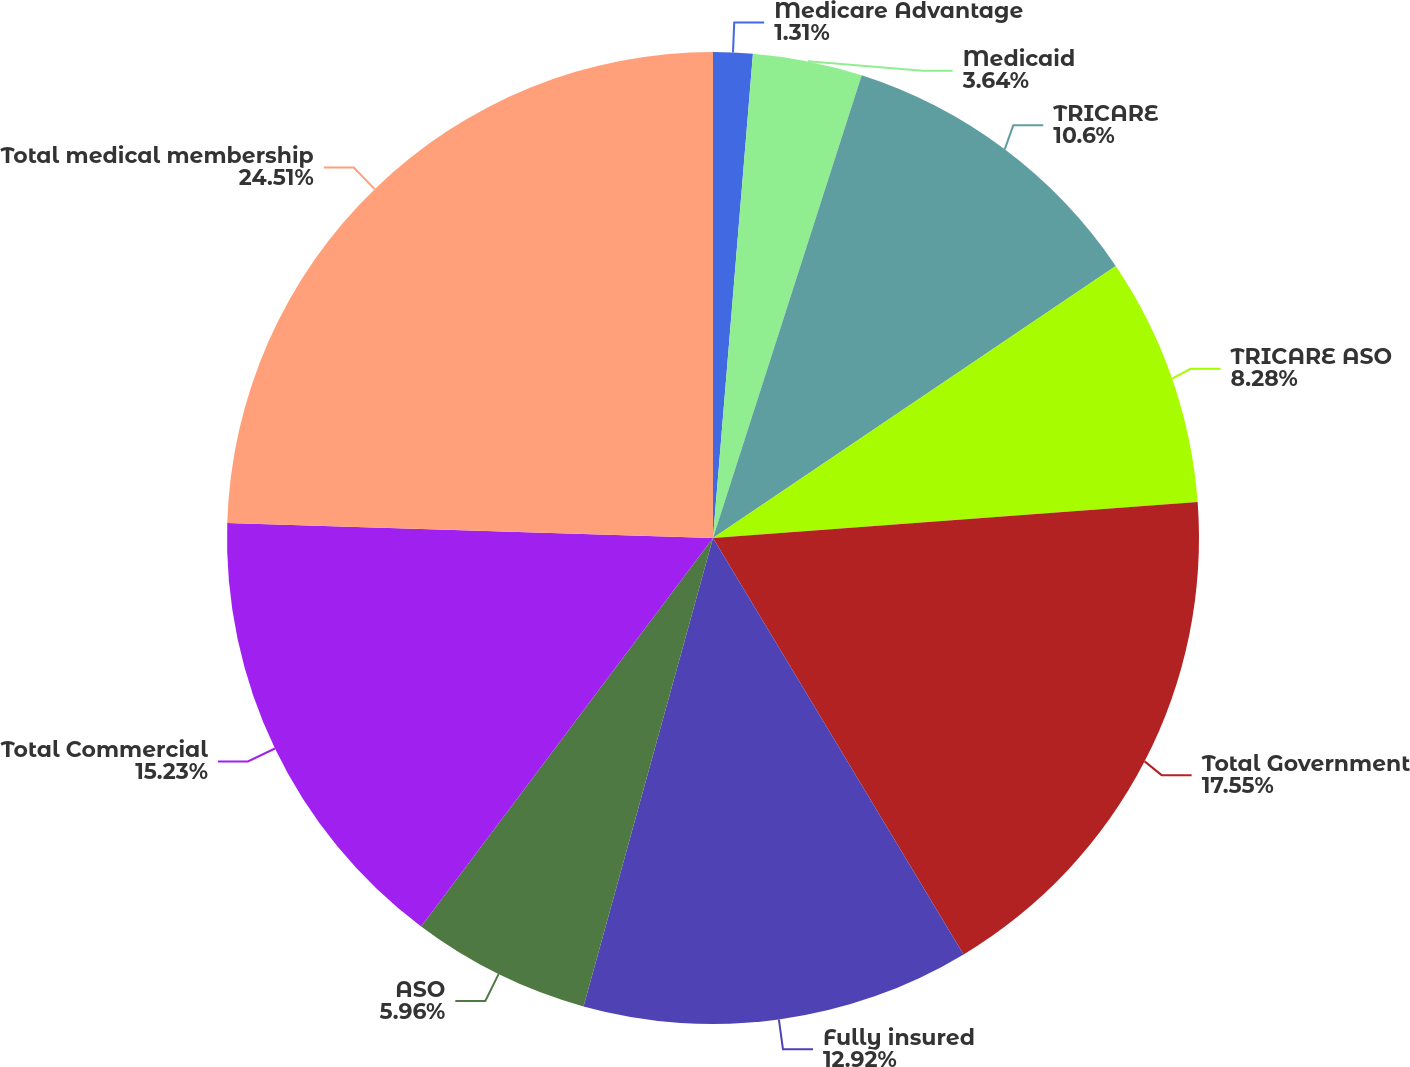Convert chart to OTSL. <chart><loc_0><loc_0><loc_500><loc_500><pie_chart><fcel>Medicare Advantage<fcel>Medicaid<fcel>TRICARE<fcel>TRICARE ASO<fcel>Total Government<fcel>Fully insured<fcel>ASO<fcel>Total Commercial<fcel>Total medical membership<nl><fcel>1.31%<fcel>3.64%<fcel>10.6%<fcel>8.28%<fcel>17.56%<fcel>12.92%<fcel>5.96%<fcel>15.24%<fcel>24.52%<nl></chart> 